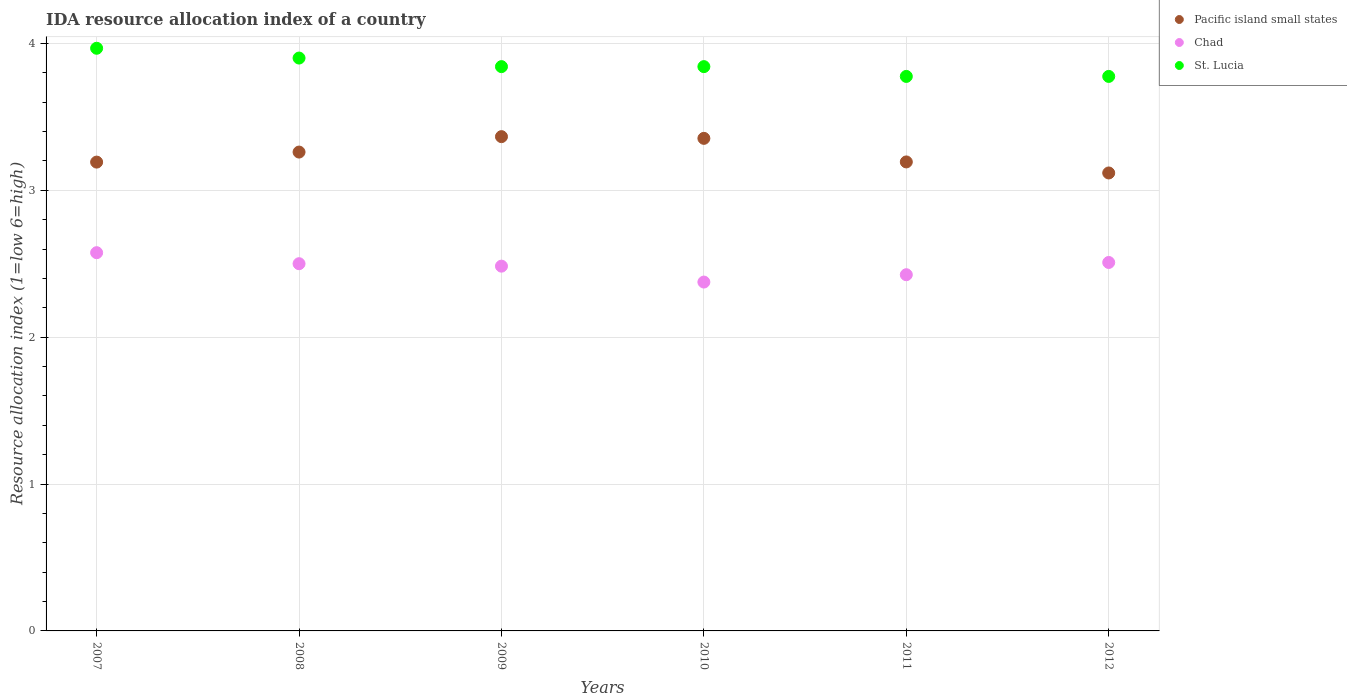Is the number of dotlines equal to the number of legend labels?
Provide a short and direct response. Yes. What is the IDA resource allocation index in Pacific island small states in 2010?
Provide a succinct answer. 3.35. Across all years, what is the maximum IDA resource allocation index in Chad?
Give a very brief answer. 2.58. Across all years, what is the minimum IDA resource allocation index in Pacific island small states?
Your answer should be compact. 3.12. In which year was the IDA resource allocation index in Chad minimum?
Your answer should be very brief. 2010. What is the total IDA resource allocation index in Chad in the graph?
Keep it short and to the point. 14.87. What is the difference between the IDA resource allocation index in Chad in 2007 and that in 2008?
Provide a succinct answer. 0.08. What is the difference between the IDA resource allocation index in Pacific island small states in 2010 and the IDA resource allocation index in St. Lucia in 2009?
Your answer should be compact. -0.49. What is the average IDA resource allocation index in Pacific island small states per year?
Your response must be concise. 3.25. In the year 2009, what is the difference between the IDA resource allocation index in Chad and IDA resource allocation index in St. Lucia?
Provide a short and direct response. -1.36. What is the ratio of the IDA resource allocation index in Chad in 2010 to that in 2012?
Give a very brief answer. 0.95. Is the IDA resource allocation index in Chad in 2008 less than that in 2009?
Offer a terse response. No. Is the difference between the IDA resource allocation index in Chad in 2007 and 2011 greater than the difference between the IDA resource allocation index in St. Lucia in 2007 and 2011?
Give a very brief answer. No. What is the difference between the highest and the second highest IDA resource allocation index in Chad?
Your answer should be very brief. 0.07. What is the difference between the highest and the lowest IDA resource allocation index in Chad?
Give a very brief answer. 0.2. In how many years, is the IDA resource allocation index in St. Lucia greater than the average IDA resource allocation index in St. Lucia taken over all years?
Offer a very short reply. 2. Is it the case that in every year, the sum of the IDA resource allocation index in Chad and IDA resource allocation index in Pacific island small states  is greater than the IDA resource allocation index in St. Lucia?
Your response must be concise. Yes. Does the IDA resource allocation index in St. Lucia monotonically increase over the years?
Offer a terse response. No. Is the IDA resource allocation index in Chad strictly greater than the IDA resource allocation index in St. Lucia over the years?
Ensure brevity in your answer.  No. Is the IDA resource allocation index in St. Lucia strictly less than the IDA resource allocation index in Pacific island small states over the years?
Make the answer very short. No. How many dotlines are there?
Provide a short and direct response. 3. How many years are there in the graph?
Your response must be concise. 6. Does the graph contain grids?
Offer a terse response. Yes. How many legend labels are there?
Offer a very short reply. 3. What is the title of the graph?
Give a very brief answer. IDA resource allocation index of a country. Does "Japan" appear as one of the legend labels in the graph?
Offer a very short reply. No. What is the label or title of the X-axis?
Your answer should be compact. Years. What is the label or title of the Y-axis?
Offer a very short reply. Resource allocation index (1=low 6=high). What is the Resource allocation index (1=low 6=high) in Pacific island small states in 2007?
Your answer should be very brief. 3.19. What is the Resource allocation index (1=low 6=high) of Chad in 2007?
Offer a very short reply. 2.58. What is the Resource allocation index (1=low 6=high) of St. Lucia in 2007?
Give a very brief answer. 3.97. What is the Resource allocation index (1=low 6=high) of Pacific island small states in 2008?
Your answer should be very brief. 3.26. What is the Resource allocation index (1=low 6=high) of Chad in 2008?
Your answer should be compact. 2.5. What is the Resource allocation index (1=low 6=high) in St. Lucia in 2008?
Keep it short and to the point. 3.9. What is the Resource allocation index (1=low 6=high) of Pacific island small states in 2009?
Make the answer very short. 3.37. What is the Resource allocation index (1=low 6=high) in Chad in 2009?
Your answer should be compact. 2.48. What is the Resource allocation index (1=low 6=high) of St. Lucia in 2009?
Make the answer very short. 3.84. What is the Resource allocation index (1=low 6=high) of Pacific island small states in 2010?
Offer a terse response. 3.35. What is the Resource allocation index (1=low 6=high) in Chad in 2010?
Make the answer very short. 2.38. What is the Resource allocation index (1=low 6=high) of St. Lucia in 2010?
Ensure brevity in your answer.  3.84. What is the Resource allocation index (1=low 6=high) of Pacific island small states in 2011?
Offer a terse response. 3.19. What is the Resource allocation index (1=low 6=high) of Chad in 2011?
Offer a terse response. 2.42. What is the Resource allocation index (1=low 6=high) of St. Lucia in 2011?
Your response must be concise. 3.77. What is the Resource allocation index (1=low 6=high) of Pacific island small states in 2012?
Offer a terse response. 3.12. What is the Resource allocation index (1=low 6=high) of Chad in 2012?
Provide a succinct answer. 2.51. What is the Resource allocation index (1=low 6=high) in St. Lucia in 2012?
Your answer should be very brief. 3.77. Across all years, what is the maximum Resource allocation index (1=low 6=high) of Pacific island small states?
Make the answer very short. 3.37. Across all years, what is the maximum Resource allocation index (1=low 6=high) in Chad?
Make the answer very short. 2.58. Across all years, what is the maximum Resource allocation index (1=low 6=high) in St. Lucia?
Make the answer very short. 3.97. Across all years, what is the minimum Resource allocation index (1=low 6=high) in Pacific island small states?
Give a very brief answer. 3.12. Across all years, what is the minimum Resource allocation index (1=low 6=high) in Chad?
Provide a short and direct response. 2.38. Across all years, what is the minimum Resource allocation index (1=low 6=high) in St. Lucia?
Give a very brief answer. 3.77. What is the total Resource allocation index (1=low 6=high) in Pacific island small states in the graph?
Ensure brevity in your answer.  19.48. What is the total Resource allocation index (1=low 6=high) in Chad in the graph?
Your answer should be compact. 14.87. What is the total Resource allocation index (1=low 6=high) of St. Lucia in the graph?
Give a very brief answer. 23.1. What is the difference between the Resource allocation index (1=low 6=high) of Pacific island small states in 2007 and that in 2008?
Offer a very short reply. -0.07. What is the difference between the Resource allocation index (1=low 6=high) in Chad in 2007 and that in 2008?
Offer a terse response. 0.07. What is the difference between the Resource allocation index (1=low 6=high) of St. Lucia in 2007 and that in 2008?
Ensure brevity in your answer.  0.07. What is the difference between the Resource allocation index (1=low 6=high) in Pacific island small states in 2007 and that in 2009?
Your response must be concise. -0.17. What is the difference between the Resource allocation index (1=low 6=high) of Chad in 2007 and that in 2009?
Ensure brevity in your answer.  0.09. What is the difference between the Resource allocation index (1=low 6=high) of Pacific island small states in 2007 and that in 2010?
Ensure brevity in your answer.  -0.16. What is the difference between the Resource allocation index (1=low 6=high) in Pacific island small states in 2007 and that in 2011?
Ensure brevity in your answer.  -0. What is the difference between the Resource allocation index (1=low 6=high) of Chad in 2007 and that in 2011?
Make the answer very short. 0.15. What is the difference between the Resource allocation index (1=low 6=high) in St. Lucia in 2007 and that in 2011?
Give a very brief answer. 0.19. What is the difference between the Resource allocation index (1=low 6=high) in Pacific island small states in 2007 and that in 2012?
Keep it short and to the point. 0.07. What is the difference between the Resource allocation index (1=low 6=high) of Chad in 2007 and that in 2012?
Your answer should be compact. 0.07. What is the difference between the Resource allocation index (1=low 6=high) in St. Lucia in 2007 and that in 2012?
Your answer should be very brief. 0.19. What is the difference between the Resource allocation index (1=low 6=high) of Pacific island small states in 2008 and that in 2009?
Give a very brief answer. -0.1. What is the difference between the Resource allocation index (1=low 6=high) of Chad in 2008 and that in 2009?
Provide a short and direct response. 0.02. What is the difference between the Resource allocation index (1=low 6=high) of St. Lucia in 2008 and that in 2009?
Your answer should be very brief. 0.06. What is the difference between the Resource allocation index (1=low 6=high) in Pacific island small states in 2008 and that in 2010?
Make the answer very short. -0.09. What is the difference between the Resource allocation index (1=low 6=high) of Chad in 2008 and that in 2010?
Give a very brief answer. 0.12. What is the difference between the Resource allocation index (1=low 6=high) of St. Lucia in 2008 and that in 2010?
Your answer should be compact. 0.06. What is the difference between the Resource allocation index (1=low 6=high) of Pacific island small states in 2008 and that in 2011?
Keep it short and to the point. 0.07. What is the difference between the Resource allocation index (1=low 6=high) in Chad in 2008 and that in 2011?
Your response must be concise. 0.07. What is the difference between the Resource allocation index (1=low 6=high) of Pacific island small states in 2008 and that in 2012?
Make the answer very short. 0.14. What is the difference between the Resource allocation index (1=low 6=high) in Chad in 2008 and that in 2012?
Give a very brief answer. -0.01. What is the difference between the Resource allocation index (1=low 6=high) in Pacific island small states in 2009 and that in 2010?
Provide a short and direct response. 0.01. What is the difference between the Resource allocation index (1=low 6=high) of Chad in 2009 and that in 2010?
Your response must be concise. 0.11. What is the difference between the Resource allocation index (1=low 6=high) of Pacific island small states in 2009 and that in 2011?
Offer a very short reply. 0.17. What is the difference between the Resource allocation index (1=low 6=high) in Chad in 2009 and that in 2011?
Offer a terse response. 0.06. What is the difference between the Resource allocation index (1=low 6=high) in St. Lucia in 2009 and that in 2011?
Give a very brief answer. 0.07. What is the difference between the Resource allocation index (1=low 6=high) in Pacific island small states in 2009 and that in 2012?
Offer a terse response. 0.25. What is the difference between the Resource allocation index (1=low 6=high) in Chad in 2009 and that in 2012?
Ensure brevity in your answer.  -0.03. What is the difference between the Resource allocation index (1=low 6=high) in St. Lucia in 2009 and that in 2012?
Make the answer very short. 0.07. What is the difference between the Resource allocation index (1=low 6=high) in Pacific island small states in 2010 and that in 2011?
Offer a very short reply. 0.16. What is the difference between the Resource allocation index (1=low 6=high) in Chad in 2010 and that in 2011?
Offer a very short reply. -0.05. What is the difference between the Resource allocation index (1=low 6=high) of St. Lucia in 2010 and that in 2011?
Your answer should be very brief. 0.07. What is the difference between the Resource allocation index (1=low 6=high) of Pacific island small states in 2010 and that in 2012?
Keep it short and to the point. 0.24. What is the difference between the Resource allocation index (1=low 6=high) in Chad in 2010 and that in 2012?
Ensure brevity in your answer.  -0.13. What is the difference between the Resource allocation index (1=low 6=high) of St. Lucia in 2010 and that in 2012?
Provide a succinct answer. 0.07. What is the difference between the Resource allocation index (1=low 6=high) in Pacific island small states in 2011 and that in 2012?
Offer a very short reply. 0.08. What is the difference between the Resource allocation index (1=low 6=high) of Chad in 2011 and that in 2012?
Offer a very short reply. -0.08. What is the difference between the Resource allocation index (1=low 6=high) of Pacific island small states in 2007 and the Resource allocation index (1=low 6=high) of Chad in 2008?
Offer a terse response. 0.69. What is the difference between the Resource allocation index (1=low 6=high) of Pacific island small states in 2007 and the Resource allocation index (1=low 6=high) of St. Lucia in 2008?
Your answer should be very brief. -0.71. What is the difference between the Resource allocation index (1=low 6=high) in Chad in 2007 and the Resource allocation index (1=low 6=high) in St. Lucia in 2008?
Offer a very short reply. -1.32. What is the difference between the Resource allocation index (1=low 6=high) in Pacific island small states in 2007 and the Resource allocation index (1=low 6=high) in Chad in 2009?
Your response must be concise. 0.71. What is the difference between the Resource allocation index (1=low 6=high) of Pacific island small states in 2007 and the Resource allocation index (1=low 6=high) of St. Lucia in 2009?
Offer a terse response. -0.65. What is the difference between the Resource allocation index (1=low 6=high) of Chad in 2007 and the Resource allocation index (1=low 6=high) of St. Lucia in 2009?
Offer a terse response. -1.27. What is the difference between the Resource allocation index (1=low 6=high) in Pacific island small states in 2007 and the Resource allocation index (1=low 6=high) in Chad in 2010?
Make the answer very short. 0.82. What is the difference between the Resource allocation index (1=low 6=high) of Pacific island small states in 2007 and the Resource allocation index (1=low 6=high) of St. Lucia in 2010?
Provide a succinct answer. -0.65. What is the difference between the Resource allocation index (1=low 6=high) of Chad in 2007 and the Resource allocation index (1=low 6=high) of St. Lucia in 2010?
Ensure brevity in your answer.  -1.27. What is the difference between the Resource allocation index (1=low 6=high) in Pacific island small states in 2007 and the Resource allocation index (1=low 6=high) in Chad in 2011?
Your answer should be compact. 0.77. What is the difference between the Resource allocation index (1=low 6=high) in Pacific island small states in 2007 and the Resource allocation index (1=low 6=high) in St. Lucia in 2011?
Make the answer very short. -0.58. What is the difference between the Resource allocation index (1=low 6=high) of Chad in 2007 and the Resource allocation index (1=low 6=high) of St. Lucia in 2011?
Give a very brief answer. -1.2. What is the difference between the Resource allocation index (1=low 6=high) of Pacific island small states in 2007 and the Resource allocation index (1=low 6=high) of Chad in 2012?
Your response must be concise. 0.68. What is the difference between the Resource allocation index (1=low 6=high) of Pacific island small states in 2007 and the Resource allocation index (1=low 6=high) of St. Lucia in 2012?
Your answer should be very brief. -0.58. What is the difference between the Resource allocation index (1=low 6=high) of Pacific island small states in 2008 and the Resource allocation index (1=low 6=high) of Chad in 2009?
Offer a very short reply. 0.78. What is the difference between the Resource allocation index (1=low 6=high) of Pacific island small states in 2008 and the Resource allocation index (1=low 6=high) of St. Lucia in 2009?
Make the answer very short. -0.58. What is the difference between the Resource allocation index (1=low 6=high) in Chad in 2008 and the Resource allocation index (1=low 6=high) in St. Lucia in 2009?
Your response must be concise. -1.34. What is the difference between the Resource allocation index (1=low 6=high) in Pacific island small states in 2008 and the Resource allocation index (1=low 6=high) in Chad in 2010?
Your answer should be compact. 0.89. What is the difference between the Resource allocation index (1=low 6=high) of Pacific island small states in 2008 and the Resource allocation index (1=low 6=high) of St. Lucia in 2010?
Keep it short and to the point. -0.58. What is the difference between the Resource allocation index (1=low 6=high) in Chad in 2008 and the Resource allocation index (1=low 6=high) in St. Lucia in 2010?
Provide a short and direct response. -1.34. What is the difference between the Resource allocation index (1=low 6=high) of Pacific island small states in 2008 and the Resource allocation index (1=low 6=high) of Chad in 2011?
Your answer should be compact. 0.83. What is the difference between the Resource allocation index (1=low 6=high) in Pacific island small states in 2008 and the Resource allocation index (1=low 6=high) in St. Lucia in 2011?
Provide a succinct answer. -0.52. What is the difference between the Resource allocation index (1=low 6=high) in Chad in 2008 and the Resource allocation index (1=low 6=high) in St. Lucia in 2011?
Give a very brief answer. -1.27. What is the difference between the Resource allocation index (1=low 6=high) in Pacific island small states in 2008 and the Resource allocation index (1=low 6=high) in Chad in 2012?
Your answer should be very brief. 0.75. What is the difference between the Resource allocation index (1=low 6=high) of Pacific island small states in 2008 and the Resource allocation index (1=low 6=high) of St. Lucia in 2012?
Make the answer very short. -0.52. What is the difference between the Resource allocation index (1=low 6=high) of Chad in 2008 and the Resource allocation index (1=low 6=high) of St. Lucia in 2012?
Provide a short and direct response. -1.27. What is the difference between the Resource allocation index (1=low 6=high) of Pacific island small states in 2009 and the Resource allocation index (1=low 6=high) of Chad in 2010?
Provide a short and direct response. 0.99. What is the difference between the Resource allocation index (1=low 6=high) in Pacific island small states in 2009 and the Resource allocation index (1=low 6=high) in St. Lucia in 2010?
Provide a succinct answer. -0.48. What is the difference between the Resource allocation index (1=low 6=high) of Chad in 2009 and the Resource allocation index (1=low 6=high) of St. Lucia in 2010?
Give a very brief answer. -1.36. What is the difference between the Resource allocation index (1=low 6=high) of Pacific island small states in 2009 and the Resource allocation index (1=low 6=high) of St. Lucia in 2011?
Keep it short and to the point. -0.41. What is the difference between the Resource allocation index (1=low 6=high) in Chad in 2009 and the Resource allocation index (1=low 6=high) in St. Lucia in 2011?
Keep it short and to the point. -1.29. What is the difference between the Resource allocation index (1=low 6=high) of Pacific island small states in 2009 and the Resource allocation index (1=low 6=high) of Chad in 2012?
Give a very brief answer. 0.86. What is the difference between the Resource allocation index (1=low 6=high) in Pacific island small states in 2009 and the Resource allocation index (1=low 6=high) in St. Lucia in 2012?
Your answer should be very brief. -0.41. What is the difference between the Resource allocation index (1=low 6=high) in Chad in 2009 and the Resource allocation index (1=low 6=high) in St. Lucia in 2012?
Your answer should be very brief. -1.29. What is the difference between the Resource allocation index (1=low 6=high) of Pacific island small states in 2010 and the Resource allocation index (1=low 6=high) of Chad in 2011?
Provide a short and direct response. 0.93. What is the difference between the Resource allocation index (1=low 6=high) of Pacific island small states in 2010 and the Resource allocation index (1=low 6=high) of St. Lucia in 2011?
Ensure brevity in your answer.  -0.42. What is the difference between the Resource allocation index (1=low 6=high) in Pacific island small states in 2010 and the Resource allocation index (1=low 6=high) in Chad in 2012?
Make the answer very short. 0.84. What is the difference between the Resource allocation index (1=low 6=high) of Pacific island small states in 2010 and the Resource allocation index (1=low 6=high) of St. Lucia in 2012?
Offer a terse response. -0.42. What is the difference between the Resource allocation index (1=low 6=high) of Chad in 2010 and the Resource allocation index (1=low 6=high) of St. Lucia in 2012?
Provide a succinct answer. -1.4. What is the difference between the Resource allocation index (1=low 6=high) in Pacific island small states in 2011 and the Resource allocation index (1=low 6=high) in Chad in 2012?
Offer a very short reply. 0.68. What is the difference between the Resource allocation index (1=low 6=high) of Pacific island small states in 2011 and the Resource allocation index (1=low 6=high) of St. Lucia in 2012?
Your answer should be very brief. -0.58. What is the difference between the Resource allocation index (1=low 6=high) in Chad in 2011 and the Resource allocation index (1=low 6=high) in St. Lucia in 2012?
Offer a terse response. -1.35. What is the average Resource allocation index (1=low 6=high) in Pacific island small states per year?
Your answer should be very brief. 3.25. What is the average Resource allocation index (1=low 6=high) of Chad per year?
Your answer should be compact. 2.48. What is the average Resource allocation index (1=low 6=high) of St. Lucia per year?
Your response must be concise. 3.85. In the year 2007, what is the difference between the Resource allocation index (1=low 6=high) in Pacific island small states and Resource allocation index (1=low 6=high) in Chad?
Give a very brief answer. 0.62. In the year 2007, what is the difference between the Resource allocation index (1=low 6=high) in Pacific island small states and Resource allocation index (1=low 6=high) in St. Lucia?
Keep it short and to the point. -0.78. In the year 2007, what is the difference between the Resource allocation index (1=low 6=high) in Chad and Resource allocation index (1=low 6=high) in St. Lucia?
Offer a terse response. -1.39. In the year 2008, what is the difference between the Resource allocation index (1=low 6=high) of Pacific island small states and Resource allocation index (1=low 6=high) of Chad?
Make the answer very short. 0.76. In the year 2008, what is the difference between the Resource allocation index (1=low 6=high) of Pacific island small states and Resource allocation index (1=low 6=high) of St. Lucia?
Provide a succinct answer. -0.64. In the year 2009, what is the difference between the Resource allocation index (1=low 6=high) of Pacific island small states and Resource allocation index (1=low 6=high) of Chad?
Your answer should be very brief. 0.88. In the year 2009, what is the difference between the Resource allocation index (1=low 6=high) of Pacific island small states and Resource allocation index (1=low 6=high) of St. Lucia?
Ensure brevity in your answer.  -0.48. In the year 2009, what is the difference between the Resource allocation index (1=low 6=high) of Chad and Resource allocation index (1=low 6=high) of St. Lucia?
Provide a short and direct response. -1.36. In the year 2010, what is the difference between the Resource allocation index (1=low 6=high) of Pacific island small states and Resource allocation index (1=low 6=high) of Chad?
Give a very brief answer. 0.98. In the year 2010, what is the difference between the Resource allocation index (1=low 6=high) of Pacific island small states and Resource allocation index (1=low 6=high) of St. Lucia?
Offer a very short reply. -0.49. In the year 2010, what is the difference between the Resource allocation index (1=low 6=high) of Chad and Resource allocation index (1=low 6=high) of St. Lucia?
Ensure brevity in your answer.  -1.47. In the year 2011, what is the difference between the Resource allocation index (1=low 6=high) in Pacific island small states and Resource allocation index (1=low 6=high) in Chad?
Provide a short and direct response. 0.77. In the year 2011, what is the difference between the Resource allocation index (1=low 6=high) of Pacific island small states and Resource allocation index (1=low 6=high) of St. Lucia?
Make the answer very short. -0.58. In the year 2011, what is the difference between the Resource allocation index (1=low 6=high) of Chad and Resource allocation index (1=low 6=high) of St. Lucia?
Ensure brevity in your answer.  -1.35. In the year 2012, what is the difference between the Resource allocation index (1=low 6=high) in Pacific island small states and Resource allocation index (1=low 6=high) in Chad?
Offer a very short reply. 0.61. In the year 2012, what is the difference between the Resource allocation index (1=low 6=high) of Pacific island small states and Resource allocation index (1=low 6=high) of St. Lucia?
Your answer should be compact. -0.66. In the year 2012, what is the difference between the Resource allocation index (1=low 6=high) of Chad and Resource allocation index (1=low 6=high) of St. Lucia?
Your response must be concise. -1.27. What is the ratio of the Resource allocation index (1=low 6=high) in Pacific island small states in 2007 to that in 2008?
Give a very brief answer. 0.98. What is the ratio of the Resource allocation index (1=low 6=high) of St. Lucia in 2007 to that in 2008?
Your answer should be compact. 1.02. What is the ratio of the Resource allocation index (1=low 6=high) of Pacific island small states in 2007 to that in 2009?
Your answer should be compact. 0.95. What is the ratio of the Resource allocation index (1=low 6=high) in Chad in 2007 to that in 2009?
Make the answer very short. 1.04. What is the ratio of the Resource allocation index (1=low 6=high) of St. Lucia in 2007 to that in 2009?
Your answer should be compact. 1.03. What is the ratio of the Resource allocation index (1=low 6=high) in Pacific island small states in 2007 to that in 2010?
Provide a succinct answer. 0.95. What is the ratio of the Resource allocation index (1=low 6=high) in Chad in 2007 to that in 2010?
Offer a terse response. 1.08. What is the ratio of the Resource allocation index (1=low 6=high) in St. Lucia in 2007 to that in 2010?
Ensure brevity in your answer.  1.03. What is the ratio of the Resource allocation index (1=low 6=high) in Pacific island small states in 2007 to that in 2011?
Make the answer very short. 1. What is the ratio of the Resource allocation index (1=low 6=high) of Chad in 2007 to that in 2011?
Your response must be concise. 1.06. What is the ratio of the Resource allocation index (1=low 6=high) of St. Lucia in 2007 to that in 2011?
Your answer should be very brief. 1.05. What is the ratio of the Resource allocation index (1=low 6=high) of Pacific island small states in 2007 to that in 2012?
Provide a succinct answer. 1.02. What is the ratio of the Resource allocation index (1=low 6=high) of Chad in 2007 to that in 2012?
Offer a terse response. 1.03. What is the ratio of the Resource allocation index (1=low 6=high) of St. Lucia in 2007 to that in 2012?
Provide a succinct answer. 1.05. What is the ratio of the Resource allocation index (1=low 6=high) of Pacific island small states in 2008 to that in 2009?
Ensure brevity in your answer.  0.97. What is the ratio of the Resource allocation index (1=low 6=high) of St. Lucia in 2008 to that in 2009?
Your answer should be very brief. 1.02. What is the ratio of the Resource allocation index (1=low 6=high) of Pacific island small states in 2008 to that in 2010?
Keep it short and to the point. 0.97. What is the ratio of the Resource allocation index (1=low 6=high) in Chad in 2008 to that in 2010?
Your response must be concise. 1.05. What is the ratio of the Resource allocation index (1=low 6=high) of St. Lucia in 2008 to that in 2010?
Your response must be concise. 1.02. What is the ratio of the Resource allocation index (1=low 6=high) of Chad in 2008 to that in 2011?
Your answer should be very brief. 1.03. What is the ratio of the Resource allocation index (1=low 6=high) of St. Lucia in 2008 to that in 2011?
Offer a terse response. 1.03. What is the ratio of the Resource allocation index (1=low 6=high) of Pacific island small states in 2008 to that in 2012?
Ensure brevity in your answer.  1.05. What is the ratio of the Resource allocation index (1=low 6=high) in St. Lucia in 2008 to that in 2012?
Provide a succinct answer. 1.03. What is the ratio of the Resource allocation index (1=low 6=high) in Chad in 2009 to that in 2010?
Offer a very short reply. 1.05. What is the ratio of the Resource allocation index (1=low 6=high) of Pacific island small states in 2009 to that in 2011?
Offer a very short reply. 1.05. What is the ratio of the Resource allocation index (1=low 6=high) of Chad in 2009 to that in 2011?
Your answer should be very brief. 1.02. What is the ratio of the Resource allocation index (1=low 6=high) of St. Lucia in 2009 to that in 2011?
Make the answer very short. 1.02. What is the ratio of the Resource allocation index (1=low 6=high) in Pacific island small states in 2009 to that in 2012?
Keep it short and to the point. 1.08. What is the ratio of the Resource allocation index (1=low 6=high) in Chad in 2009 to that in 2012?
Provide a succinct answer. 0.99. What is the ratio of the Resource allocation index (1=low 6=high) in St. Lucia in 2009 to that in 2012?
Keep it short and to the point. 1.02. What is the ratio of the Resource allocation index (1=low 6=high) of Pacific island small states in 2010 to that in 2011?
Your answer should be very brief. 1.05. What is the ratio of the Resource allocation index (1=low 6=high) in Chad in 2010 to that in 2011?
Make the answer very short. 0.98. What is the ratio of the Resource allocation index (1=low 6=high) of St. Lucia in 2010 to that in 2011?
Make the answer very short. 1.02. What is the ratio of the Resource allocation index (1=low 6=high) of Pacific island small states in 2010 to that in 2012?
Keep it short and to the point. 1.08. What is the ratio of the Resource allocation index (1=low 6=high) of Chad in 2010 to that in 2012?
Give a very brief answer. 0.95. What is the ratio of the Resource allocation index (1=low 6=high) of St. Lucia in 2010 to that in 2012?
Your answer should be very brief. 1.02. What is the ratio of the Resource allocation index (1=low 6=high) of Pacific island small states in 2011 to that in 2012?
Your response must be concise. 1.02. What is the ratio of the Resource allocation index (1=low 6=high) of Chad in 2011 to that in 2012?
Your response must be concise. 0.97. What is the difference between the highest and the second highest Resource allocation index (1=low 6=high) of Pacific island small states?
Keep it short and to the point. 0.01. What is the difference between the highest and the second highest Resource allocation index (1=low 6=high) of Chad?
Your answer should be compact. 0.07. What is the difference between the highest and the second highest Resource allocation index (1=low 6=high) in St. Lucia?
Provide a succinct answer. 0.07. What is the difference between the highest and the lowest Resource allocation index (1=low 6=high) in Pacific island small states?
Offer a terse response. 0.25. What is the difference between the highest and the lowest Resource allocation index (1=low 6=high) of Chad?
Offer a very short reply. 0.2. What is the difference between the highest and the lowest Resource allocation index (1=low 6=high) of St. Lucia?
Make the answer very short. 0.19. 